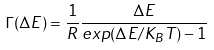Convert formula to latex. <formula><loc_0><loc_0><loc_500><loc_500>\Gamma ( \Delta E ) = \frac { 1 } { R } \frac { \Delta E } { e x p ( \Delta E / K _ { B } T ) - 1 }</formula> 